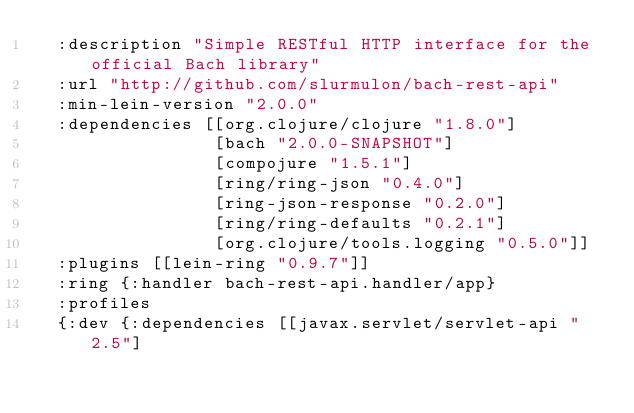<code> <loc_0><loc_0><loc_500><loc_500><_Clojure_>  :description "Simple RESTful HTTP interface for the official Bach library"
  :url "http://github.com/slurmulon/bach-rest-api"
  :min-lein-version "2.0.0"
  :dependencies [[org.clojure/clojure "1.8.0"]
                 [bach "2.0.0-SNAPSHOT"]
                 [compojure "1.5.1"]
                 [ring/ring-json "0.4.0"]
                 [ring-json-response "0.2.0"]
                 [ring/ring-defaults "0.2.1"]
                 [org.clojure/tools.logging "0.5.0"]]
  :plugins [[lein-ring "0.9.7"]]
  :ring {:handler bach-rest-api.handler/app}
  :profiles
  {:dev {:dependencies [[javax.servlet/servlet-api "2.5"]</code> 